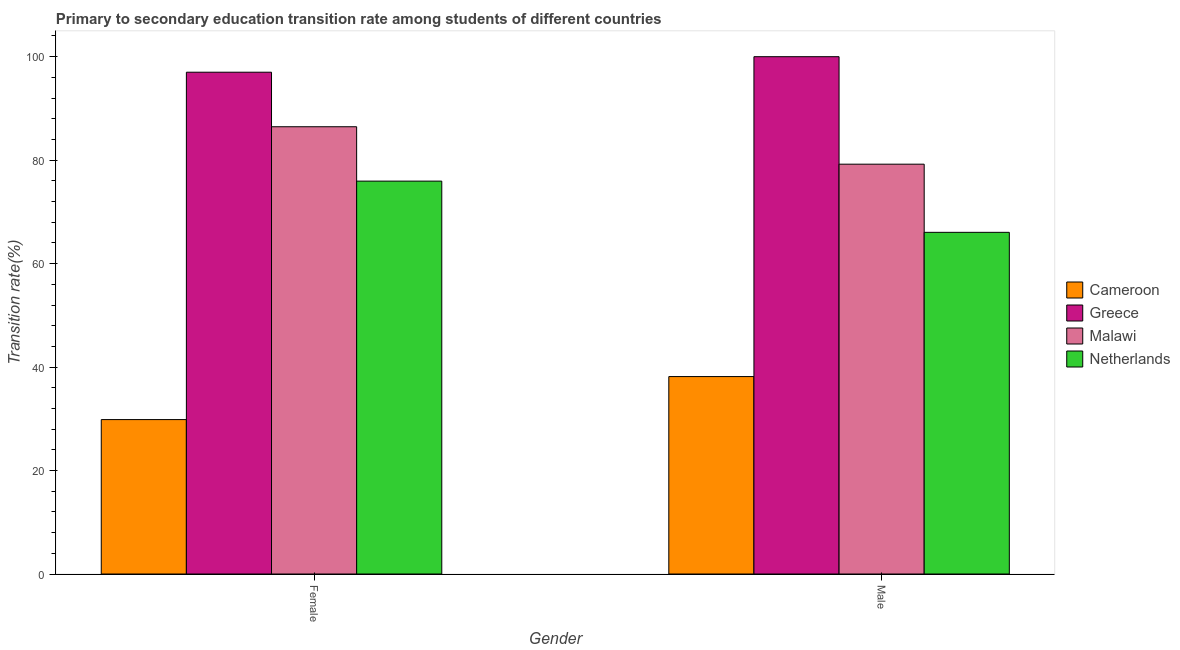Are the number of bars per tick equal to the number of legend labels?
Make the answer very short. Yes. Are the number of bars on each tick of the X-axis equal?
Keep it short and to the point. Yes. How many bars are there on the 1st tick from the left?
Keep it short and to the point. 4. What is the transition rate among male students in Malawi?
Provide a succinct answer. 79.22. Across all countries, what is the maximum transition rate among male students?
Keep it short and to the point. 100. Across all countries, what is the minimum transition rate among female students?
Your answer should be compact. 29.85. In which country was the transition rate among female students minimum?
Keep it short and to the point. Cameroon. What is the total transition rate among female students in the graph?
Your response must be concise. 289.26. What is the difference between the transition rate among female students in Cameroon and that in Greece?
Your answer should be compact. -67.15. What is the difference between the transition rate among female students in Cameroon and the transition rate among male students in Greece?
Make the answer very short. -70.15. What is the average transition rate among female students per country?
Make the answer very short. 72.31. What is the difference between the transition rate among female students and transition rate among male students in Greece?
Provide a succinct answer. -3. What is the ratio of the transition rate among male students in Cameroon to that in Greece?
Keep it short and to the point. 0.38. Is the transition rate among male students in Malawi less than that in Cameroon?
Give a very brief answer. No. In how many countries, is the transition rate among male students greater than the average transition rate among male students taken over all countries?
Your answer should be compact. 2. What does the 2nd bar from the left in Male represents?
Offer a very short reply. Greece. How many bars are there?
Give a very brief answer. 8. Are all the bars in the graph horizontal?
Offer a terse response. No. What is the difference between two consecutive major ticks on the Y-axis?
Make the answer very short. 20. Are the values on the major ticks of Y-axis written in scientific E-notation?
Your answer should be compact. No. Does the graph contain grids?
Your answer should be compact. No. How many legend labels are there?
Ensure brevity in your answer.  4. How are the legend labels stacked?
Offer a very short reply. Vertical. What is the title of the graph?
Your answer should be compact. Primary to secondary education transition rate among students of different countries. Does "Bulgaria" appear as one of the legend labels in the graph?
Offer a terse response. No. What is the label or title of the X-axis?
Provide a short and direct response. Gender. What is the label or title of the Y-axis?
Ensure brevity in your answer.  Transition rate(%). What is the Transition rate(%) of Cameroon in Female?
Your answer should be compact. 29.85. What is the Transition rate(%) in Greece in Female?
Your answer should be very brief. 97. What is the Transition rate(%) of Malawi in Female?
Keep it short and to the point. 86.46. What is the Transition rate(%) in Netherlands in Female?
Offer a terse response. 75.95. What is the Transition rate(%) in Cameroon in Male?
Offer a very short reply. 38.16. What is the Transition rate(%) in Greece in Male?
Offer a very short reply. 100. What is the Transition rate(%) of Malawi in Male?
Provide a succinct answer. 79.22. What is the Transition rate(%) of Netherlands in Male?
Your answer should be compact. 66.05. Across all Gender, what is the maximum Transition rate(%) of Cameroon?
Provide a short and direct response. 38.16. Across all Gender, what is the maximum Transition rate(%) in Greece?
Provide a short and direct response. 100. Across all Gender, what is the maximum Transition rate(%) of Malawi?
Ensure brevity in your answer.  86.46. Across all Gender, what is the maximum Transition rate(%) of Netherlands?
Offer a very short reply. 75.95. Across all Gender, what is the minimum Transition rate(%) in Cameroon?
Offer a terse response. 29.85. Across all Gender, what is the minimum Transition rate(%) of Greece?
Provide a succinct answer. 97. Across all Gender, what is the minimum Transition rate(%) of Malawi?
Make the answer very short. 79.22. Across all Gender, what is the minimum Transition rate(%) of Netherlands?
Your answer should be compact. 66.05. What is the total Transition rate(%) of Cameroon in the graph?
Your answer should be very brief. 68.01. What is the total Transition rate(%) of Greece in the graph?
Offer a very short reply. 197. What is the total Transition rate(%) of Malawi in the graph?
Your answer should be very brief. 165.68. What is the total Transition rate(%) in Netherlands in the graph?
Ensure brevity in your answer.  142. What is the difference between the Transition rate(%) in Cameroon in Female and that in Male?
Offer a very short reply. -8.31. What is the difference between the Transition rate(%) in Greece in Female and that in Male?
Provide a succinct answer. -3. What is the difference between the Transition rate(%) in Malawi in Female and that in Male?
Your answer should be very brief. 7.23. What is the difference between the Transition rate(%) in Netherlands in Female and that in Male?
Your answer should be compact. 9.9. What is the difference between the Transition rate(%) of Cameroon in Female and the Transition rate(%) of Greece in Male?
Offer a terse response. -70.15. What is the difference between the Transition rate(%) of Cameroon in Female and the Transition rate(%) of Malawi in Male?
Provide a short and direct response. -49.37. What is the difference between the Transition rate(%) of Cameroon in Female and the Transition rate(%) of Netherlands in Male?
Keep it short and to the point. -36.2. What is the difference between the Transition rate(%) in Greece in Female and the Transition rate(%) in Malawi in Male?
Make the answer very short. 17.78. What is the difference between the Transition rate(%) in Greece in Female and the Transition rate(%) in Netherlands in Male?
Offer a terse response. 30.95. What is the difference between the Transition rate(%) in Malawi in Female and the Transition rate(%) in Netherlands in Male?
Your response must be concise. 20.41. What is the average Transition rate(%) of Cameroon per Gender?
Your answer should be compact. 34.01. What is the average Transition rate(%) of Greece per Gender?
Keep it short and to the point. 98.5. What is the average Transition rate(%) of Malawi per Gender?
Offer a very short reply. 82.84. What is the average Transition rate(%) in Netherlands per Gender?
Your answer should be compact. 71. What is the difference between the Transition rate(%) of Cameroon and Transition rate(%) of Greece in Female?
Provide a succinct answer. -67.15. What is the difference between the Transition rate(%) of Cameroon and Transition rate(%) of Malawi in Female?
Give a very brief answer. -56.61. What is the difference between the Transition rate(%) of Cameroon and Transition rate(%) of Netherlands in Female?
Offer a terse response. -46.1. What is the difference between the Transition rate(%) in Greece and Transition rate(%) in Malawi in Female?
Provide a short and direct response. 10.54. What is the difference between the Transition rate(%) of Greece and Transition rate(%) of Netherlands in Female?
Keep it short and to the point. 21.05. What is the difference between the Transition rate(%) of Malawi and Transition rate(%) of Netherlands in Female?
Provide a succinct answer. 10.51. What is the difference between the Transition rate(%) in Cameroon and Transition rate(%) in Greece in Male?
Give a very brief answer. -61.84. What is the difference between the Transition rate(%) of Cameroon and Transition rate(%) of Malawi in Male?
Your answer should be very brief. -41.06. What is the difference between the Transition rate(%) in Cameroon and Transition rate(%) in Netherlands in Male?
Give a very brief answer. -27.88. What is the difference between the Transition rate(%) of Greece and Transition rate(%) of Malawi in Male?
Give a very brief answer. 20.78. What is the difference between the Transition rate(%) in Greece and Transition rate(%) in Netherlands in Male?
Give a very brief answer. 33.95. What is the difference between the Transition rate(%) of Malawi and Transition rate(%) of Netherlands in Male?
Make the answer very short. 13.18. What is the ratio of the Transition rate(%) in Cameroon in Female to that in Male?
Give a very brief answer. 0.78. What is the ratio of the Transition rate(%) of Greece in Female to that in Male?
Make the answer very short. 0.97. What is the ratio of the Transition rate(%) of Malawi in Female to that in Male?
Make the answer very short. 1.09. What is the ratio of the Transition rate(%) in Netherlands in Female to that in Male?
Make the answer very short. 1.15. What is the difference between the highest and the second highest Transition rate(%) in Cameroon?
Provide a short and direct response. 8.31. What is the difference between the highest and the second highest Transition rate(%) in Greece?
Make the answer very short. 3. What is the difference between the highest and the second highest Transition rate(%) of Malawi?
Your answer should be compact. 7.23. What is the difference between the highest and the second highest Transition rate(%) in Netherlands?
Offer a terse response. 9.9. What is the difference between the highest and the lowest Transition rate(%) in Cameroon?
Your answer should be very brief. 8.31. What is the difference between the highest and the lowest Transition rate(%) in Greece?
Offer a terse response. 3. What is the difference between the highest and the lowest Transition rate(%) in Malawi?
Provide a succinct answer. 7.23. What is the difference between the highest and the lowest Transition rate(%) of Netherlands?
Provide a succinct answer. 9.9. 